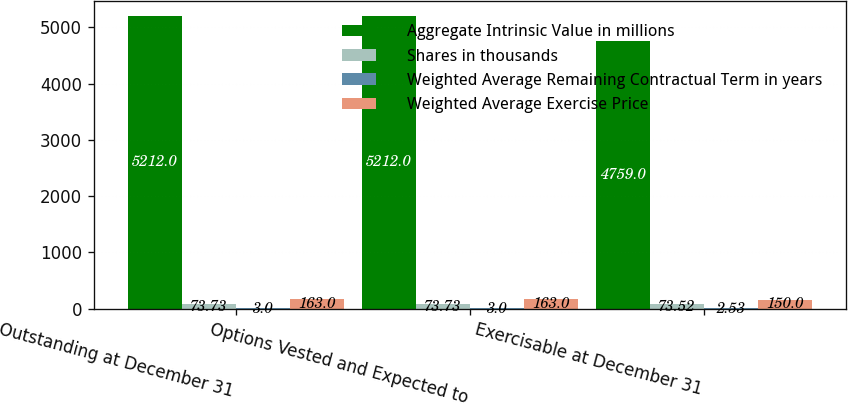Convert chart to OTSL. <chart><loc_0><loc_0><loc_500><loc_500><stacked_bar_chart><ecel><fcel>Outstanding at December 31<fcel>Options Vested and Expected to<fcel>Exercisable at December 31<nl><fcel>Aggregate Intrinsic Value in millions<fcel>5212<fcel>5212<fcel>4759<nl><fcel>Shares in thousands<fcel>73.73<fcel>73.73<fcel>73.52<nl><fcel>Weighted Average Remaining Contractual Term in years<fcel>3<fcel>3<fcel>2.53<nl><fcel>Weighted Average Exercise Price<fcel>163<fcel>163<fcel>150<nl></chart> 